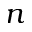Convert formula to latex. <formula><loc_0><loc_0><loc_500><loc_500>n</formula> 